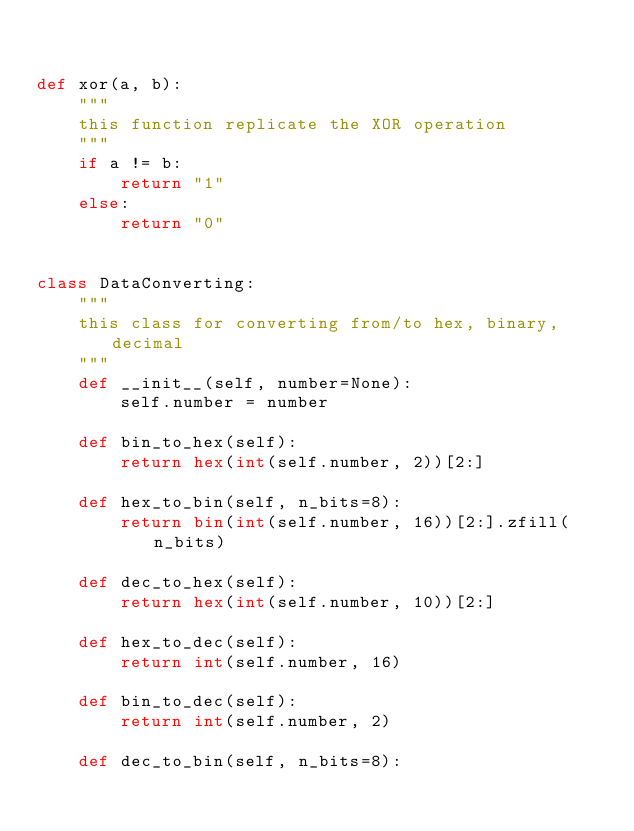<code> <loc_0><loc_0><loc_500><loc_500><_Python_>

def xor(a, b):
    """
    this function replicate the XOR operation
    """
    if a != b:
        return "1"
    else:
        return "0"


class DataConverting:
    """
    this class for converting from/to hex, binary, decimal
    """
    def __init__(self, number=None):
        self.number = number

    def bin_to_hex(self):
        return hex(int(self.number, 2))[2:]

    def hex_to_bin(self, n_bits=8):
        return bin(int(self.number, 16))[2:].zfill(n_bits)

    def dec_to_hex(self):
        return hex(int(self.number, 10))[2:]

    def hex_to_dec(self):
        return int(self.number, 16)

    def bin_to_dec(self):
        return int(self.number, 2)

    def dec_to_bin(self, n_bits=8):</code> 